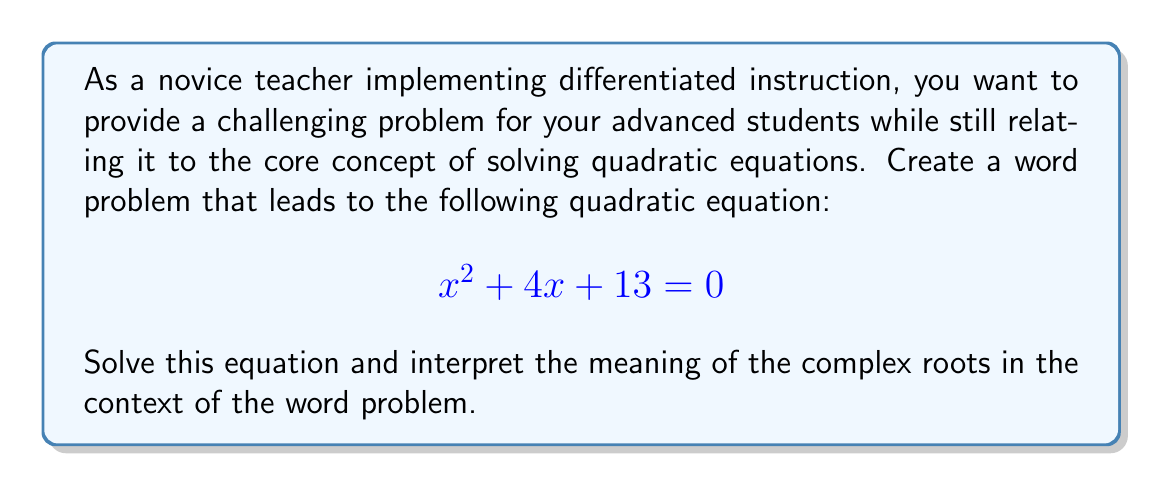Help me with this question. To solve this problem, we'll follow these steps:

1) First, let's solve the quadratic equation $x^2 + 4x + 13 = 0$

2) We can use the quadratic formula: $x = \frac{-b \pm \sqrt{b^2 - 4ac}}{2a}$

   Where $a = 1$, $b = 4$, and $c = 13$

3) Substituting these values:

   $$x = \frac{-4 \pm \sqrt{4^2 - 4(1)(13)}}{2(1)}$$

4) Simplify under the square root:

   $$x = \frac{-4 \pm \sqrt{16 - 52}}{2} = \frac{-4 \pm \sqrt{-36}}{2}$$

5) Simplify further:

   $$x = \frac{-4 \pm 6i}{2}$$

6) Separate the real and imaginary parts:

   $$x = -2 \pm 3i$$

7) Therefore, the two complex roots are:

   $x_1 = -2 + 3i$ and $x_2 = -2 - 3i$

Interpretation in the context of a word problem:

Let's frame this in terms of a physics problem about simple harmonic motion. The equation could represent the position of an object over time in a damped oscillatory system.

In this context:
- The real part (-2) represents the decay or damping of the system over time.
- The imaginary part (±3i) represents the oscillation of the system.

The complex roots indicate that the system will oscillate while gradually decreasing in amplitude over time, never quite reaching the equilibrium position but getting closer and closer to it.

This type of problem allows advanced students to connect abstract mathematical concepts (complex roots) with real-world applications, deepening their understanding and engagement with the material.
Answer: The complex roots of the equation $x^2 + 4x + 13 = 0$ are:

$x_1 = -2 + 3i$ and $x_2 = -2 - 3i$

In the context of a damped oscillatory system, these roots indicate a decaying oscillation over time. 